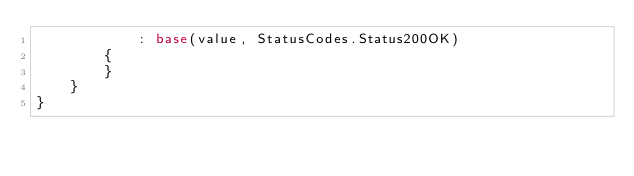<code> <loc_0><loc_0><loc_500><loc_500><_C#_>            : base(value, StatusCodes.Status200OK)
        {
        }
    }
}
</code> 